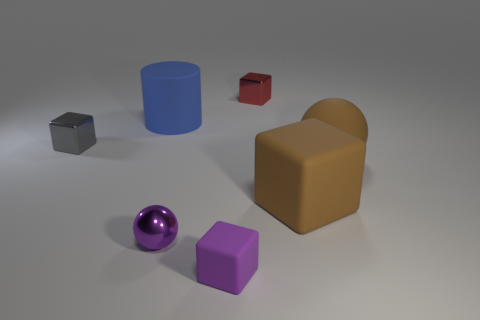What time of day or lighting conditions does the image suggest? The image suggests an indoor environment under artificial lighting. There are multiple shadows cast by the objects that hint at a light source positioned above the scene, commonly found in interior settings. 